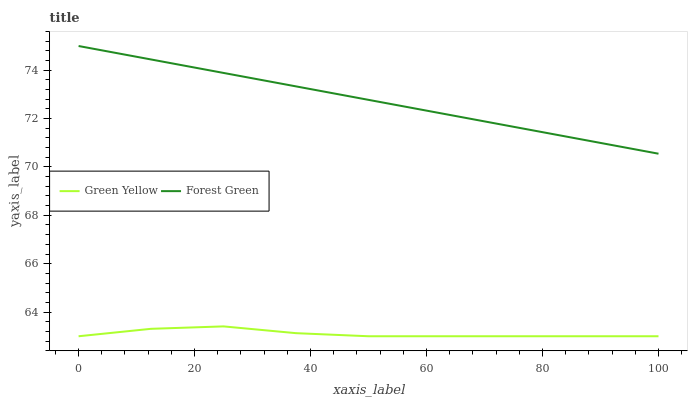Does Green Yellow have the minimum area under the curve?
Answer yes or no. Yes. Does Forest Green have the maximum area under the curve?
Answer yes or no. Yes. Does Green Yellow have the maximum area under the curve?
Answer yes or no. No. Is Forest Green the smoothest?
Answer yes or no. Yes. Is Green Yellow the roughest?
Answer yes or no. Yes. Is Green Yellow the smoothest?
Answer yes or no. No. Does Green Yellow have the highest value?
Answer yes or no. No. Is Green Yellow less than Forest Green?
Answer yes or no. Yes. Is Forest Green greater than Green Yellow?
Answer yes or no. Yes. Does Green Yellow intersect Forest Green?
Answer yes or no. No. 